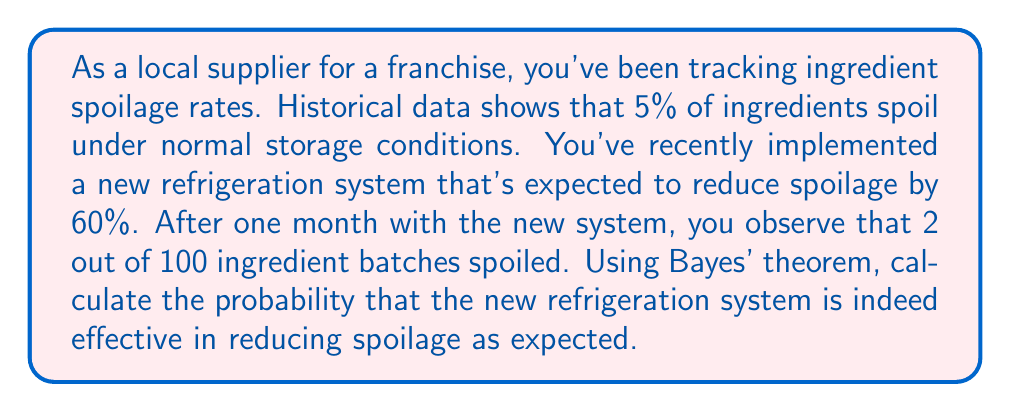Give your solution to this math problem. Let's approach this problem using Bayes' theorem. We'll define our events as follows:

$E$: The new refrigeration system is effective (reduces spoilage by 60%)
$D$: The observed data (2 out of 100 batches spoiled)

We want to calculate $P(E|D)$, the probability that the system is effective given our observed data.

Bayes' theorem states:

$$P(E|D) = \frac{P(D|E) \cdot P(E)}{P(D)}$$

Let's calculate each component:

1) $P(E)$: Prior probability that the system is effective. We'll assume a neutral prior of 0.5.

2) $P(D|E)$: Probability of observing 2 spoiled batches out of 100 if the system is effective.
   If effective, the new spoilage rate should be $5\% \cdot (1 - 60\%) = 2\%$
   We can model this as a binomial distribution:
   $$P(D|E) = \binom{100}{2} \cdot (0.02)^2 \cdot (0.98)^{98} \approx 0.2700$$

3) $P(D|\text{not}E)$: Probability of observing 2 spoiled batches out of 100 if the system is not effective.
   If not effective, the spoilage rate remains 5%
   $$P(D|\text{not}E) = \binom{100}{2} \cdot (0.05)^2 \cdot (0.95)^{98} \approx 0.0884$$

4) $P(D)$: Total probability of the observed data
   $$P(D) = P(D|E) \cdot P(E) + P(D|\text{not}E) \cdot P(\text{not}E)$$
   $$P(D) = 0.2700 \cdot 0.5 + 0.0884 \cdot 0.5 = 0.1792$$

Now we can apply Bayes' theorem:

$$P(E|D) = \frac{0.2700 \cdot 0.5}{0.1792} \approx 0.7535$$
Answer: The probability that the new refrigeration system is effective in reducing spoilage as expected, given the observed data, is approximately 0.7535 or 75.35%. 